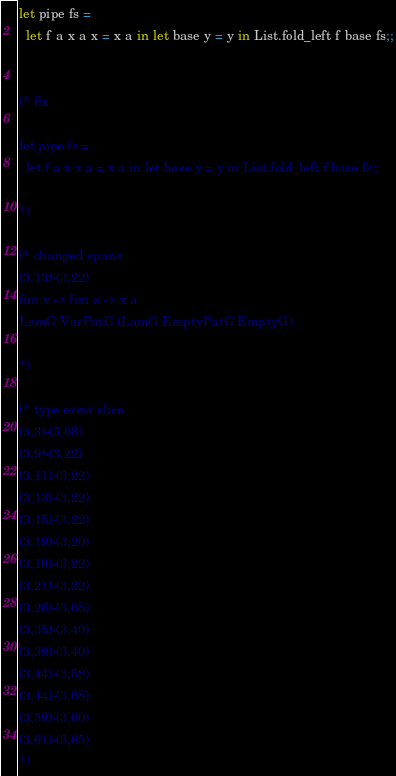<code> <loc_0><loc_0><loc_500><loc_500><_OCaml_>
let pipe fs =
  let f a x a x = x a in let base y = y in List.fold_left f base fs;;


(* fix

let pipe fs =
  let f a x x a = x a in let base y = y in List.fold_left f base fs;;

*)

(* changed spans
(3,13)-(3,22)
fun x -> fun a -> x a
LamG VarPatG (LamG EmptyPatG EmptyG)

*)

(* type error slice
(3,3)-(3,68)
(3,9)-(3,22)
(3,11)-(3,22)
(3,13)-(3,22)
(3,15)-(3,22)
(3,19)-(3,20)
(3,19)-(3,22)
(3,21)-(3,22)
(3,26)-(3,68)
(3,35)-(3,40)
(3,39)-(3,40)
(3,44)-(3,58)
(3,44)-(3,68)
(3,59)-(3,60)
(3,61)-(3,65)
*)
</code> 